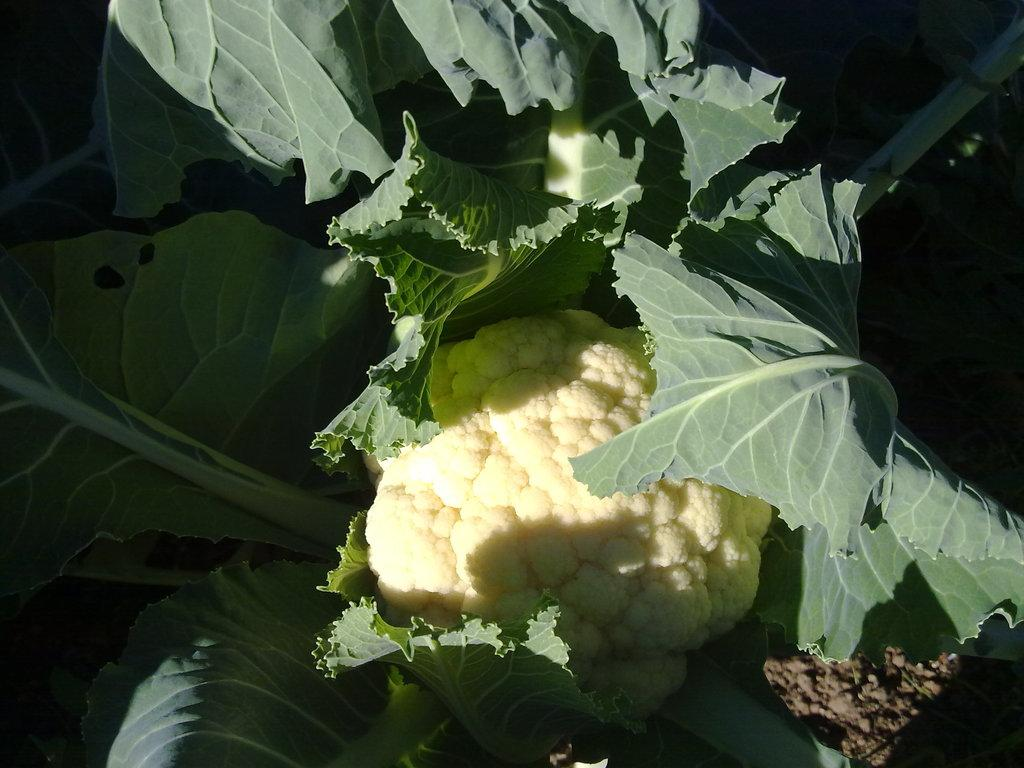What vegetable is present in the image? There is a cauliflower in the image. What type of doll can be seen playing with an arch in the image? There is no doll or arch present in the image; it only features a cauliflower. 